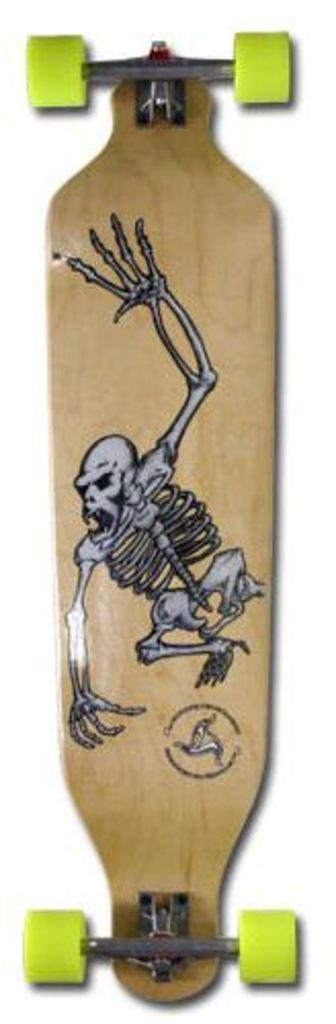What is the main object in the image? There is a skateboard in the image. What color are the wheels of the skateboard? The skateboard wheels are green. What image is on the skateboard? There is a skeleton image on the skateboard. How much tax is being paid on the clam in the image? There is no clam present in the image, and therefore no tax can be associated with it. 